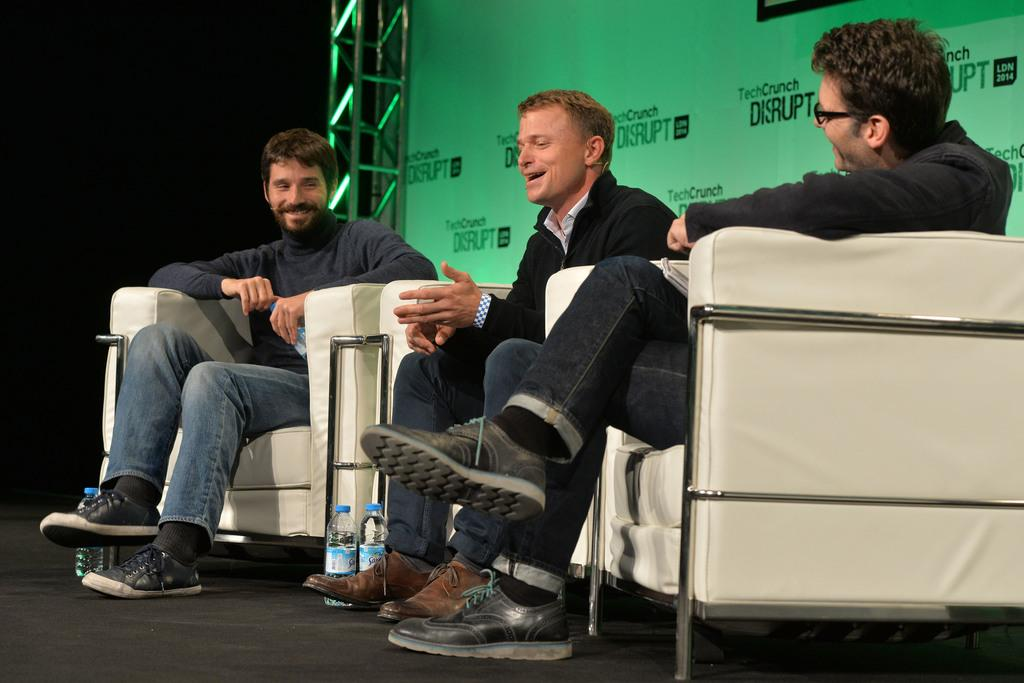How many people are in the image? There is a group of people in the image. What are the people doing in the image? The people are seated on a sofa. What objects can be seen besides the people in the image? There are bottles visible in the image. What can be seen in the background of the image? There is a metal pole and a hoarding in the background of the image. What type of owl can be seen sitting on the hoarding in the image? There is no owl present in the image; it only features a group of people, bottles, a metal pole, and a hoarding. What color is the jelly that the people are eating on the sofa? There is no jelly mentioned or visible in the image. 